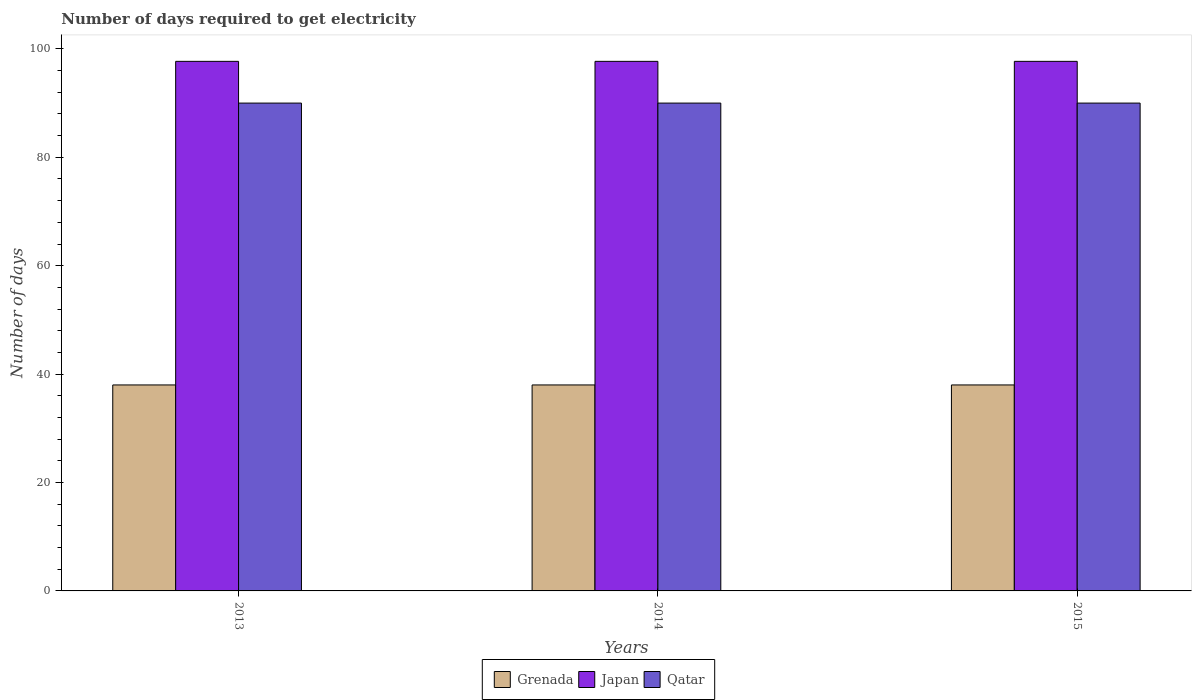Are the number of bars per tick equal to the number of legend labels?
Give a very brief answer. Yes. Are the number of bars on each tick of the X-axis equal?
Make the answer very short. Yes. How many bars are there on the 2nd tick from the left?
Provide a succinct answer. 3. How many bars are there on the 1st tick from the right?
Ensure brevity in your answer.  3. What is the label of the 3rd group of bars from the left?
Give a very brief answer. 2015. What is the number of days required to get electricity in in Qatar in 2015?
Offer a very short reply. 90. Across all years, what is the maximum number of days required to get electricity in in Japan?
Give a very brief answer. 97.7. Across all years, what is the minimum number of days required to get electricity in in Qatar?
Your answer should be compact. 90. What is the total number of days required to get electricity in in Grenada in the graph?
Make the answer very short. 114. What is the difference between the number of days required to get electricity in in Qatar in 2015 and the number of days required to get electricity in in Japan in 2014?
Give a very brief answer. -7.7. What is the average number of days required to get electricity in in Japan per year?
Your answer should be very brief. 97.7. In the year 2015, what is the difference between the number of days required to get electricity in in Qatar and number of days required to get electricity in in Japan?
Your answer should be very brief. -7.7. Is the difference between the number of days required to get electricity in in Qatar in 2013 and 2014 greater than the difference between the number of days required to get electricity in in Japan in 2013 and 2014?
Offer a very short reply. No. In how many years, is the number of days required to get electricity in in Qatar greater than the average number of days required to get electricity in in Qatar taken over all years?
Keep it short and to the point. 0. What does the 3rd bar from the left in 2013 represents?
Your answer should be compact. Qatar. What does the 2nd bar from the right in 2013 represents?
Your answer should be very brief. Japan. Are all the bars in the graph horizontal?
Give a very brief answer. No. How many years are there in the graph?
Keep it short and to the point. 3. Does the graph contain grids?
Your response must be concise. No. How many legend labels are there?
Ensure brevity in your answer.  3. What is the title of the graph?
Offer a very short reply. Number of days required to get electricity. What is the label or title of the Y-axis?
Provide a succinct answer. Number of days. What is the Number of days of Grenada in 2013?
Provide a short and direct response. 38. What is the Number of days of Japan in 2013?
Provide a short and direct response. 97.7. What is the Number of days of Qatar in 2013?
Provide a short and direct response. 90. What is the Number of days in Japan in 2014?
Provide a short and direct response. 97.7. What is the Number of days in Japan in 2015?
Provide a succinct answer. 97.7. Across all years, what is the maximum Number of days in Grenada?
Make the answer very short. 38. Across all years, what is the maximum Number of days in Japan?
Give a very brief answer. 97.7. Across all years, what is the maximum Number of days in Qatar?
Provide a short and direct response. 90. Across all years, what is the minimum Number of days of Japan?
Keep it short and to the point. 97.7. Across all years, what is the minimum Number of days of Qatar?
Ensure brevity in your answer.  90. What is the total Number of days of Grenada in the graph?
Offer a terse response. 114. What is the total Number of days in Japan in the graph?
Make the answer very short. 293.1. What is the total Number of days in Qatar in the graph?
Provide a succinct answer. 270. What is the difference between the Number of days in Japan in 2013 and that in 2014?
Keep it short and to the point. 0. What is the difference between the Number of days in Grenada in 2013 and that in 2015?
Your answer should be very brief. 0. What is the difference between the Number of days in Japan in 2013 and that in 2015?
Your response must be concise. 0. What is the difference between the Number of days of Grenada in 2014 and that in 2015?
Provide a short and direct response. 0. What is the difference between the Number of days in Japan in 2014 and that in 2015?
Give a very brief answer. 0. What is the difference between the Number of days of Grenada in 2013 and the Number of days of Japan in 2014?
Your answer should be very brief. -59.7. What is the difference between the Number of days in Grenada in 2013 and the Number of days in Qatar in 2014?
Make the answer very short. -52. What is the difference between the Number of days of Grenada in 2013 and the Number of days of Japan in 2015?
Offer a terse response. -59.7. What is the difference between the Number of days in Grenada in 2013 and the Number of days in Qatar in 2015?
Your answer should be very brief. -52. What is the difference between the Number of days of Japan in 2013 and the Number of days of Qatar in 2015?
Your answer should be very brief. 7.7. What is the difference between the Number of days of Grenada in 2014 and the Number of days of Japan in 2015?
Ensure brevity in your answer.  -59.7. What is the difference between the Number of days of Grenada in 2014 and the Number of days of Qatar in 2015?
Provide a succinct answer. -52. What is the average Number of days of Japan per year?
Provide a short and direct response. 97.7. In the year 2013, what is the difference between the Number of days of Grenada and Number of days of Japan?
Keep it short and to the point. -59.7. In the year 2013, what is the difference between the Number of days in Grenada and Number of days in Qatar?
Your answer should be very brief. -52. In the year 2014, what is the difference between the Number of days of Grenada and Number of days of Japan?
Provide a short and direct response. -59.7. In the year 2014, what is the difference between the Number of days of Grenada and Number of days of Qatar?
Offer a terse response. -52. In the year 2015, what is the difference between the Number of days in Grenada and Number of days in Japan?
Provide a short and direct response. -59.7. In the year 2015, what is the difference between the Number of days of Grenada and Number of days of Qatar?
Offer a terse response. -52. In the year 2015, what is the difference between the Number of days in Japan and Number of days in Qatar?
Make the answer very short. 7.7. What is the ratio of the Number of days of Japan in 2013 to that in 2014?
Make the answer very short. 1. What is the ratio of the Number of days in Japan in 2013 to that in 2015?
Make the answer very short. 1. What is the difference between the highest and the second highest Number of days of Qatar?
Offer a very short reply. 0. 